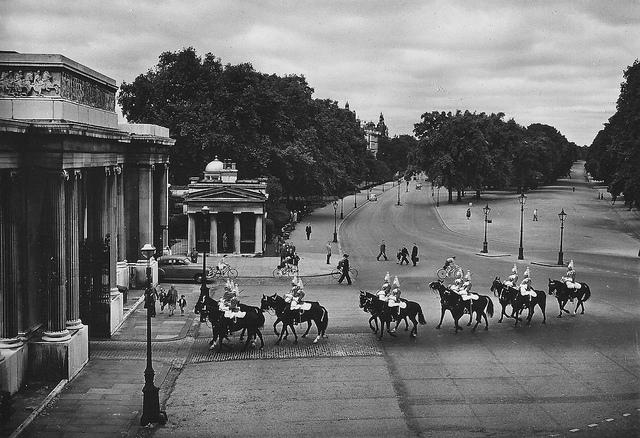How many horses are there?
Concise answer only. 11. Are the horses in unison?
Short answer required. Yes. What era was this photo taken?
Concise answer only. 1950's. 